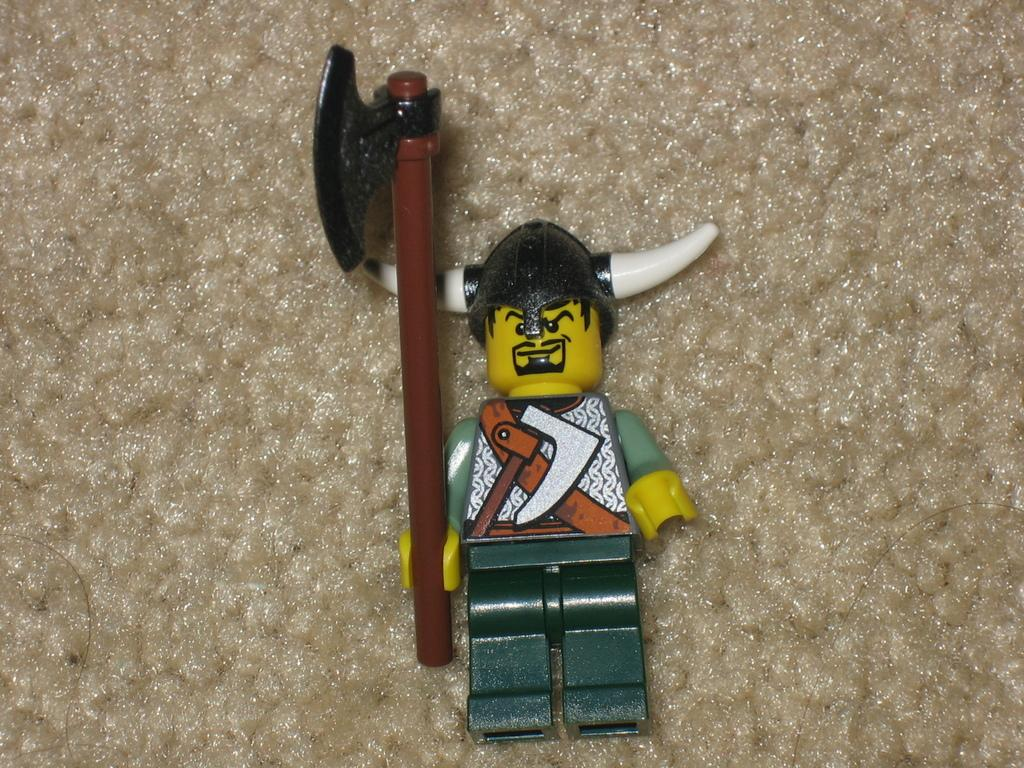What is the main subject in the center of the image? There is a toy in the center of the image. What type of loaf is being used to play with the toy in the image? There is no loaf present in the image, and therefore no such interaction can be observed. 